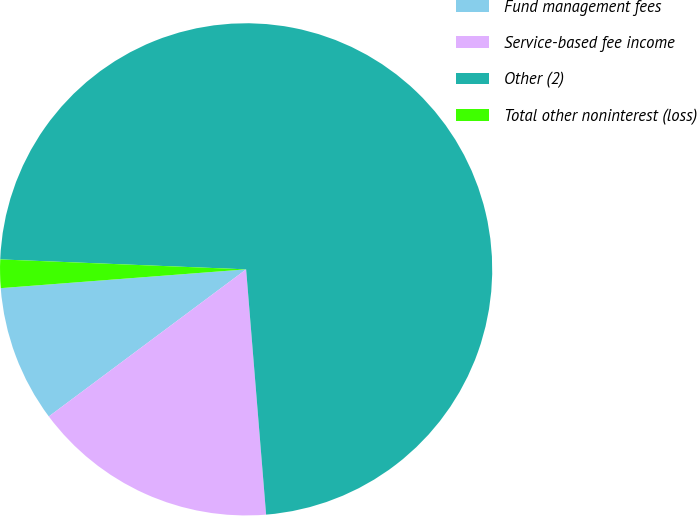<chart> <loc_0><loc_0><loc_500><loc_500><pie_chart><fcel>Fund management fees<fcel>Service-based fee income<fcel>Other (2)<fcel>Total other noninterest (loss)<nl><fcel>8.98%<fcel>16.1%<fcel>73.07%<fcel>1.86%<nl></chart> 